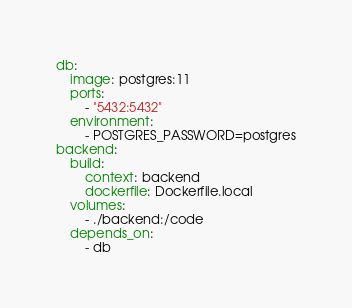Convert code to text. <code><loc_0><loc_0><loc_500><loc_500><_YAML_>db:
    image: postgres:11
    ports:
        - "5432:5432"
    environment:
        - POSTGRES_PASSWORD=postgres
backend:
    build:
        context: backend
        dockerfile: Dockerfile.local
    volumes:
        - ./backend:/code
    depends_on:
        - db
</code> 